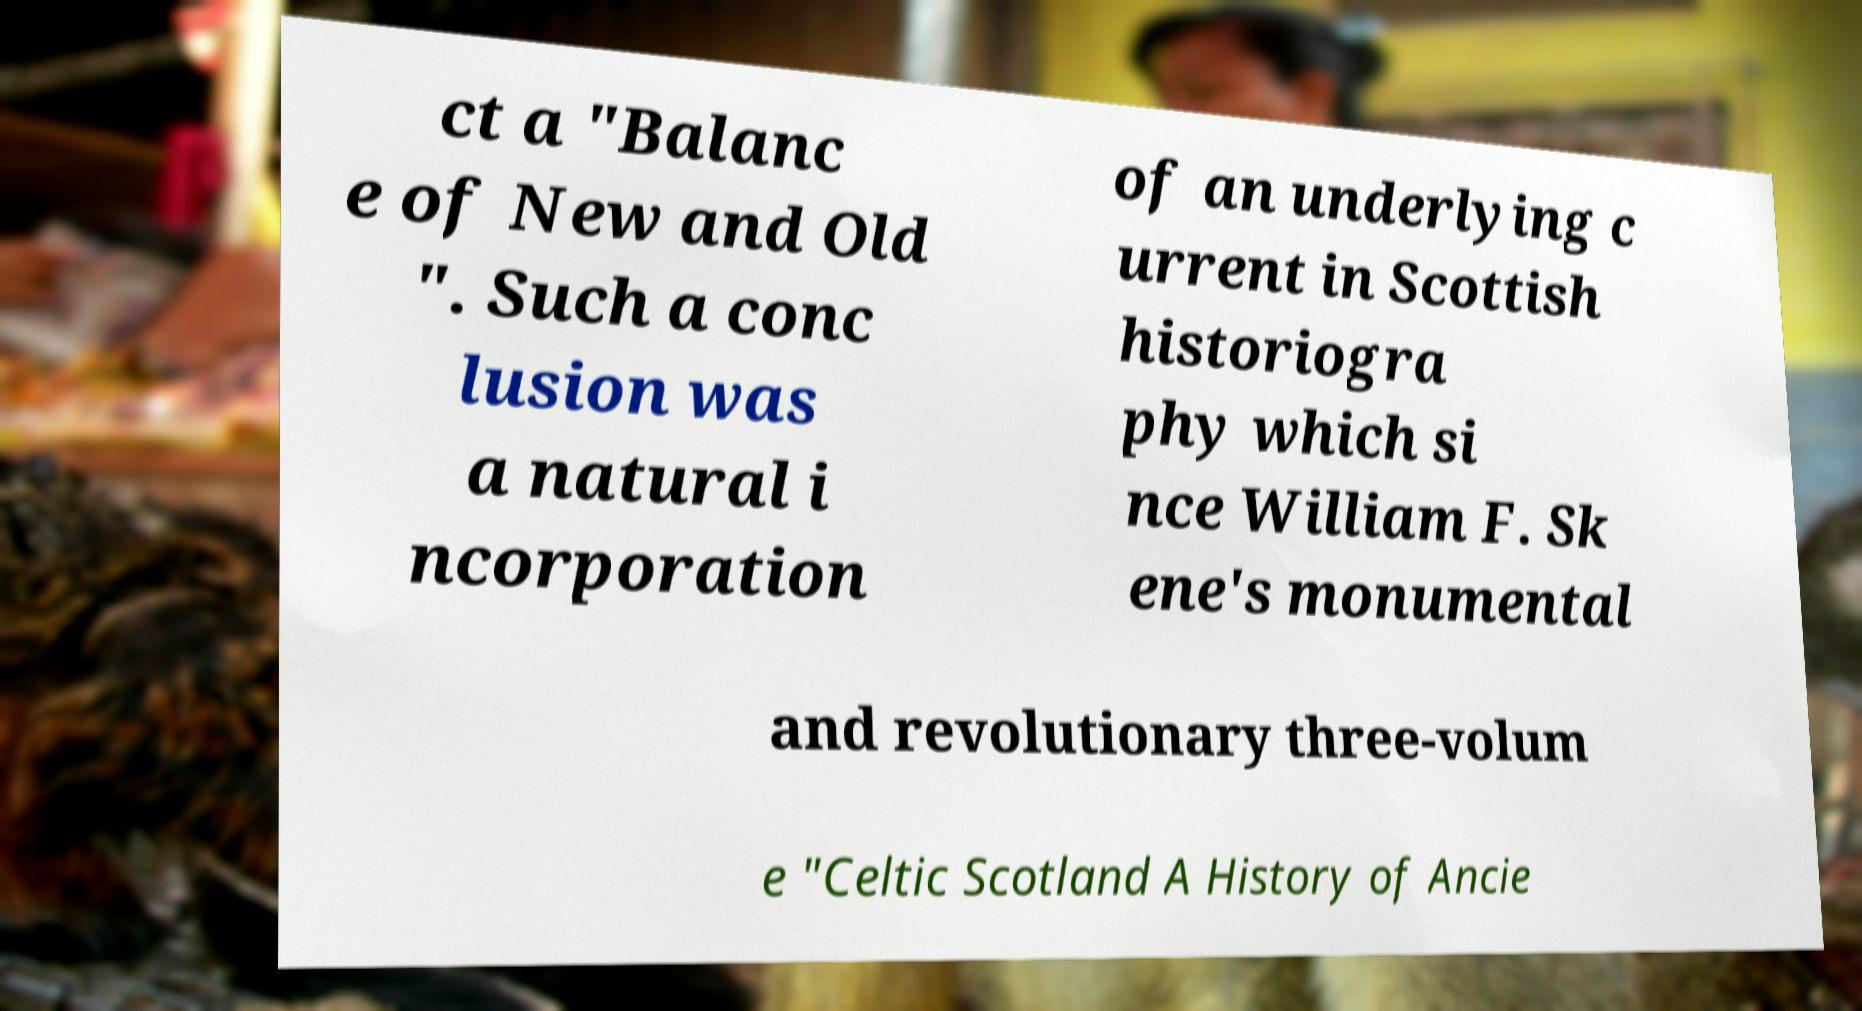Can you accurately transcribe the text from the provided image for me? ct a "Balanc e of New and Old ". Such a conc lusion was a natural i ncorporation of an underlying c urrent in Scottish historiogra phy which si nce William F. Sk ene's monumental and revolutionary three-volum e "Celtic Scotland A History of Ancie 